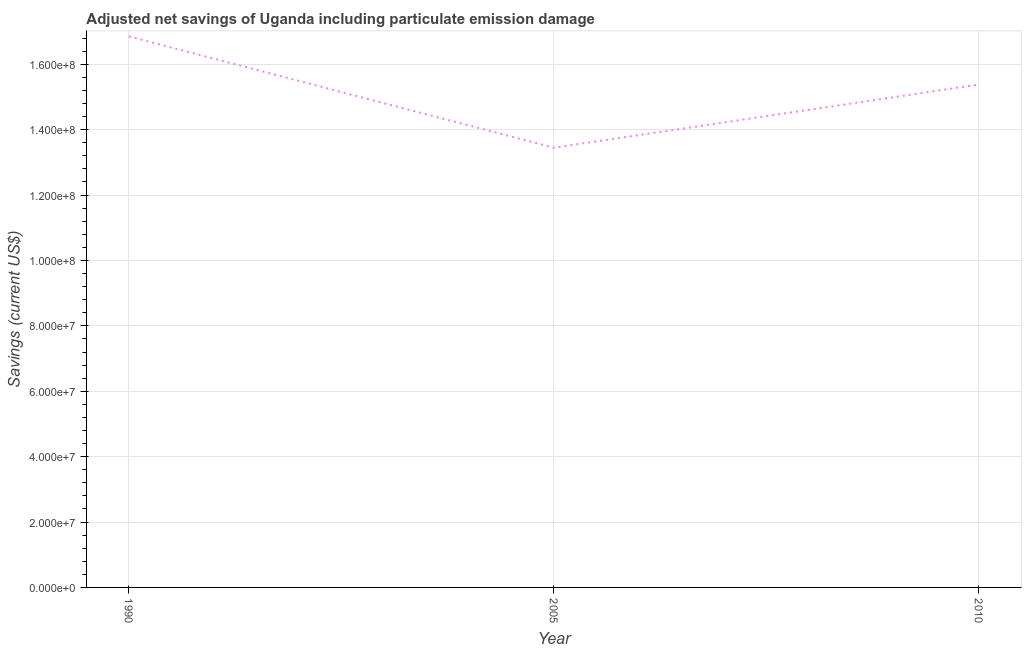What is the adjusted net savings in 1990?
Make the answer very short. 1.69e+08. Across all years, what is the maximum adjusted net savings?
Make the answer very short. 1.69e+08. Across all years, what is the minimum adjusted net savings?
Provide a succinct answer. 1.34e+08. In which year was the adjusted net savings maximum?
Your response must be concise. 1990. What is the sum of the adjusted net savings?
Your response must be concise. 4.57e+08. What is the difference between the adjusted net savings in 1990 and 2005?
Your answer should be very brief. 3.41e+07. What is the average adjusted net savings per year?
Make the answer very short. 1.52e+08. What is the median adjusted net savings?
Your answer should be compact. 1.54e+08. What is the ratio of the adjusted net savings in 1990 to that in 2010?
Ensure brevity in your answer.  1.1. Is the difference between the adjusted net savings in 1990 and 2010 greater than the difference between any two years?
Your answer should be very brief. No. What is the difference between the highest and the second highest adjusted net savings?
Offer a very short reply. 1.47e+07. Is the sum of the adjusted net savings in 1990 and 2005 greater than the maximum adjusted net savings across all years?
Your answer should be compact. Yes. What is the difference between the highest and the lowest adjusted net savings?
Provide a succinct answer. 3.41e+07. In how many years, is the adjusted net savings greater than the average adjusted net savings taken over all years?
Your answer should be very brief. 2. How many years are there in the graph?
Offer a terse response. 3. Are the values on the major ticks of Y-axis written in scientific E-notation?
Offer a terse response. Yes. Does the graph contain any zero values?
Your answer should be very brief. No. Does the graph contain grids?
Your answer should be very brief. Yes. What is the title of the graph?
Your answer should be compact. Adjusted net savings of Uganda including particulate emission damage. What is the label or title of the X-axis?
Your answer should be very brief. Year. What is the label or title of the Y-axis?
Provide a short and direct response. Savings (current US$). What is the Savings (current US$) of 1990?
Offer a very short reply. 1.69e+08. What is the Savings (current US$) in 2005?
Offer a very short reply. 1.34e+08. What is the Savings (current US$) of 2010?
Provide a short and direct response. 1.54e+08. What is the difference between the Savings (current US$) in 1990 and 2005?
Provide a succinct answer. 3.41e+07. What is the difference between the Savings (current US$) in 1990 and 2010?
Offer a very short reply. 1.47e+07. What is the difference between the Savings (current US$) in 2005 and 2010?
Ensure brevity in your answer.  -1.93e+07. What is the ratio of the Savings (current US$) in 1990 to that in 2005?
Give a very brief answer. 1.25. What is the ratio of the Savings (current US$) in 1990 to that in 2010?
Keep it short and to the point. 1.1. What is the ratio of the Savings (current US$) in 2005 to that in 2010?
Ensure brevity in your answer.  0.87. 